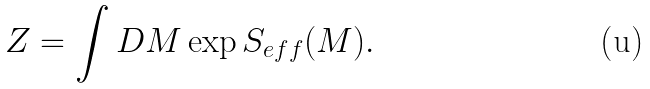<formula> <loc_0><loc_0><loc_500><loc_500>Z = \int D M \exp S _ { e f f } ( M ) .</formula> 